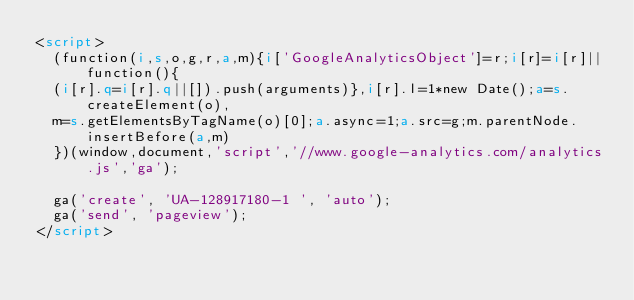Convert code to text. <code><loc_0><loc_0><loc_500><loc_500><_HTML_><script>
  (function(i,s,o,g,r,a,m){i['GoogleAnalyticsObject']=r;i[r]=i[r]||function(){
  (i[r].q=i[r].q||[]).push(arguments)},i[r].l=1*new Date();a=s.createElement(o),
  m=s.getElementsByTagName(o)[0];a.async=1;a.src=g;m.parentNode.insertBefore(a,m)
  })(window,document,'script','//www.google-analytics.com/analytics.js','ga');

  ga('create', 'UA-128917180-1 ', 'auto');
  ga('send', 'pageview');
</script>
</code> 